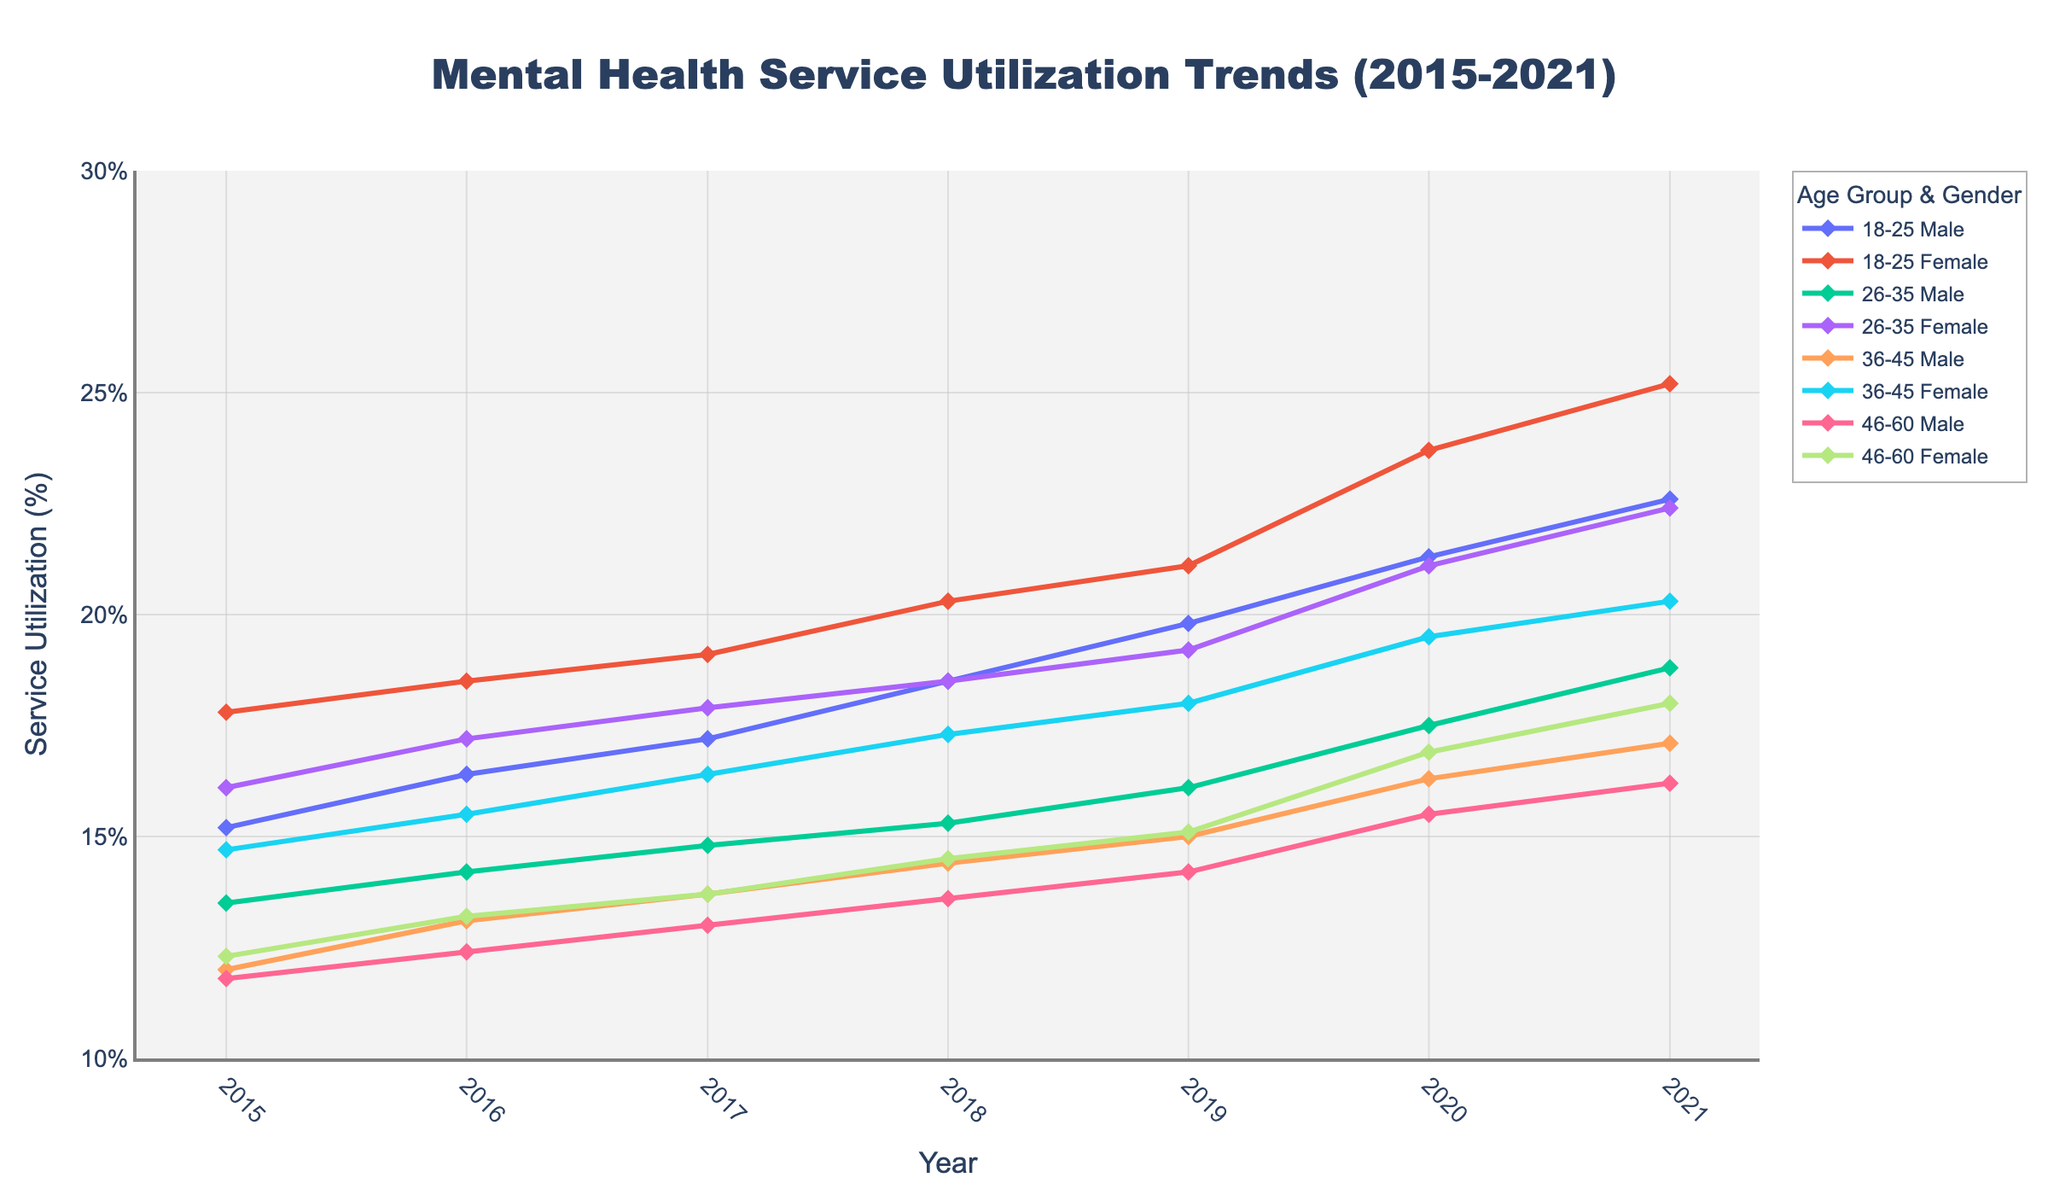What is the title of the figure? The title is usually located at the top center of the figure. It provides a brief summary of what the figure represents.
Answer: Mental Health Service Utilization Trends (2015-2021) What are the x and y-axes labels? Axes labels are typically written beside or below the axes. They describe what each axis measures. In this figure, the x-axis represents time in years, and the y-axis represents the percentage of service utilization.
Answer: The x-axis label is "Year", and the y-axis label is "Service Utilization (%)" Which age group and gender had the highest service utilization in 2021? To find the highest value, look for the peak point in 2021. Trace back to the corresponding age group and gender in the legend, which maps line colors and markers to groups.
Answer: 18-25 Female What is the general trend for mental health service utilization for the 18-25 age group from 2015 to 2021? Observe the lines corresponding to the 18-25 age group for both males and females by looking at their trends from left (2015) to right (2021). Both lines generally show an increase over time, indicating a rising trend.
Answer: Increasing Compare the service utilization trend between males and females aged 46-60. To compare trends, observe both the male and female lines for the 46-60 age group from 2015 to 2021. Both show an increasing trend, but females have consistently higher utilization, especially noticeable in later years.
Answer: Females aged 46-60 utilized services more How much did the service utilization for males aged 18-25 increase from 2015 to 2021? Find the service utilization percentages for males aged 18-25 in 2015 and 2021. Calculate the difference to find the increase (22.6% in 2021 - 15.2% in 2015).
Answer: 7.4% Describe any noticeable differences in the trends of service utilization between the 26-35 and 36-45 age groups for females from 2015 to 2021. Track the service utilization lines for females aged 26-35 and 36-45 from 2015 to 2021. Both trends are upward; however, females aged 26-35 have a steeper increase compared to females aged 36-45.
Answer: 26-35 age group has a steeper increase Which year shows the highest overall mental health service utilization across all groups? Identify the peak value in the entire plot and trace it back to the corresponding year along the x-axis. 2021 has the highest peaks for many age and gender groups.
Answer: 2021 